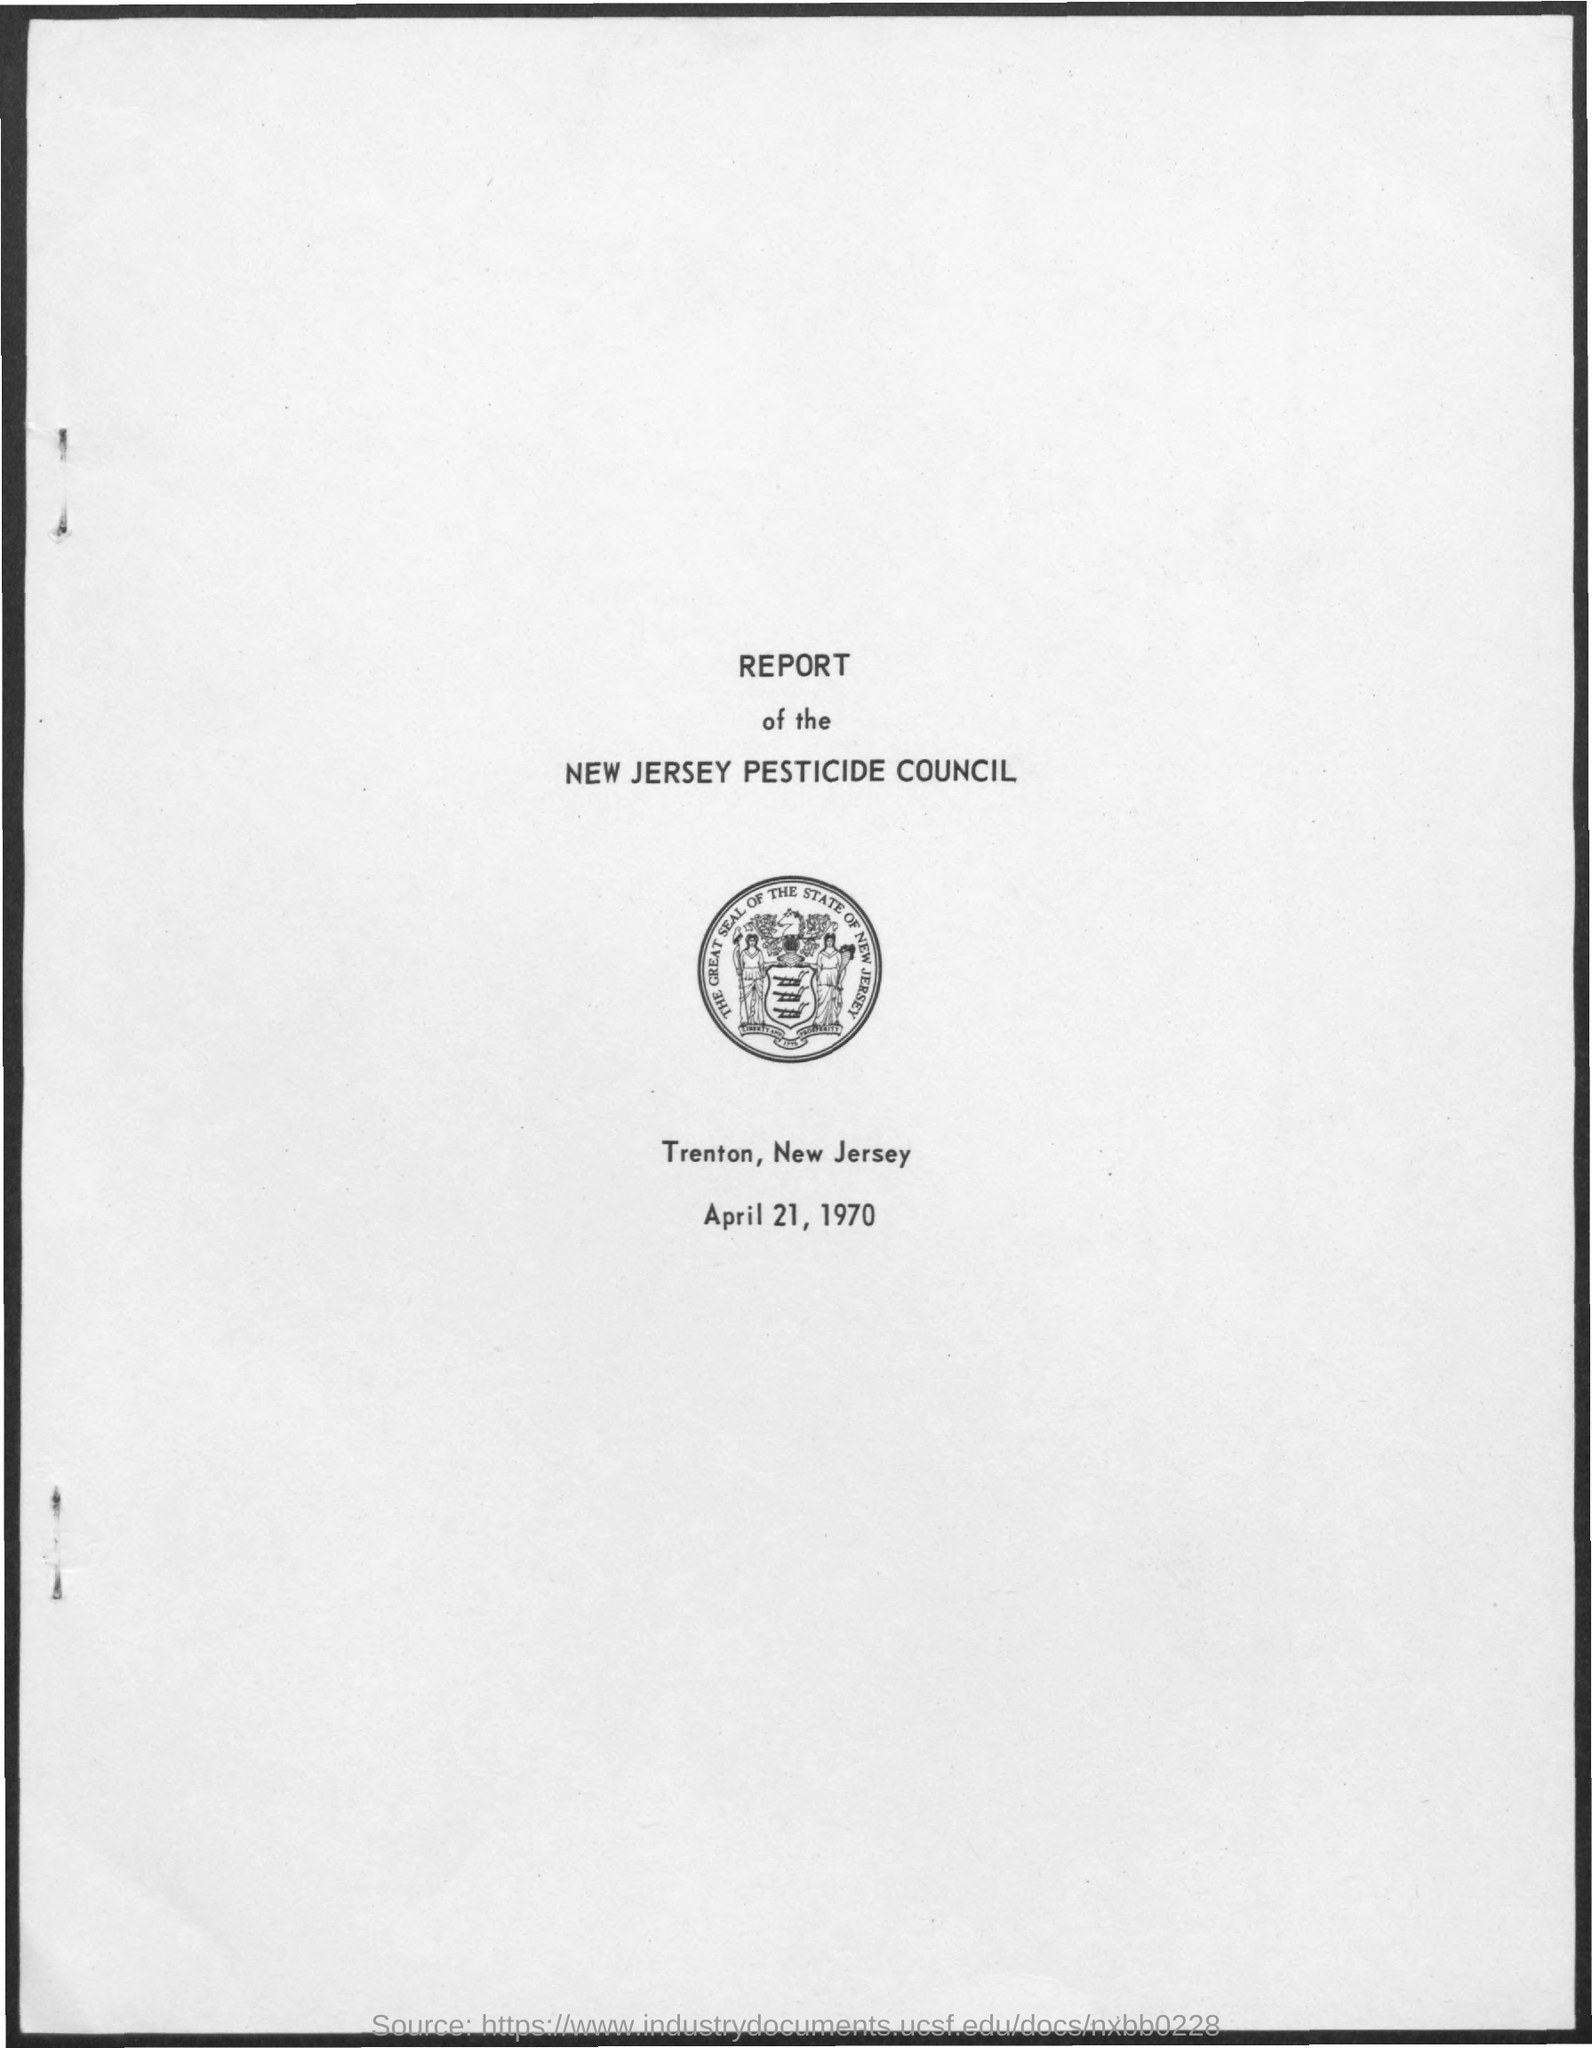Whose report is it?
Offer a very short reply. New Jersey Pesticide Council. What is the date on the document?
Provide a succinct answer. April 21, 1970. 